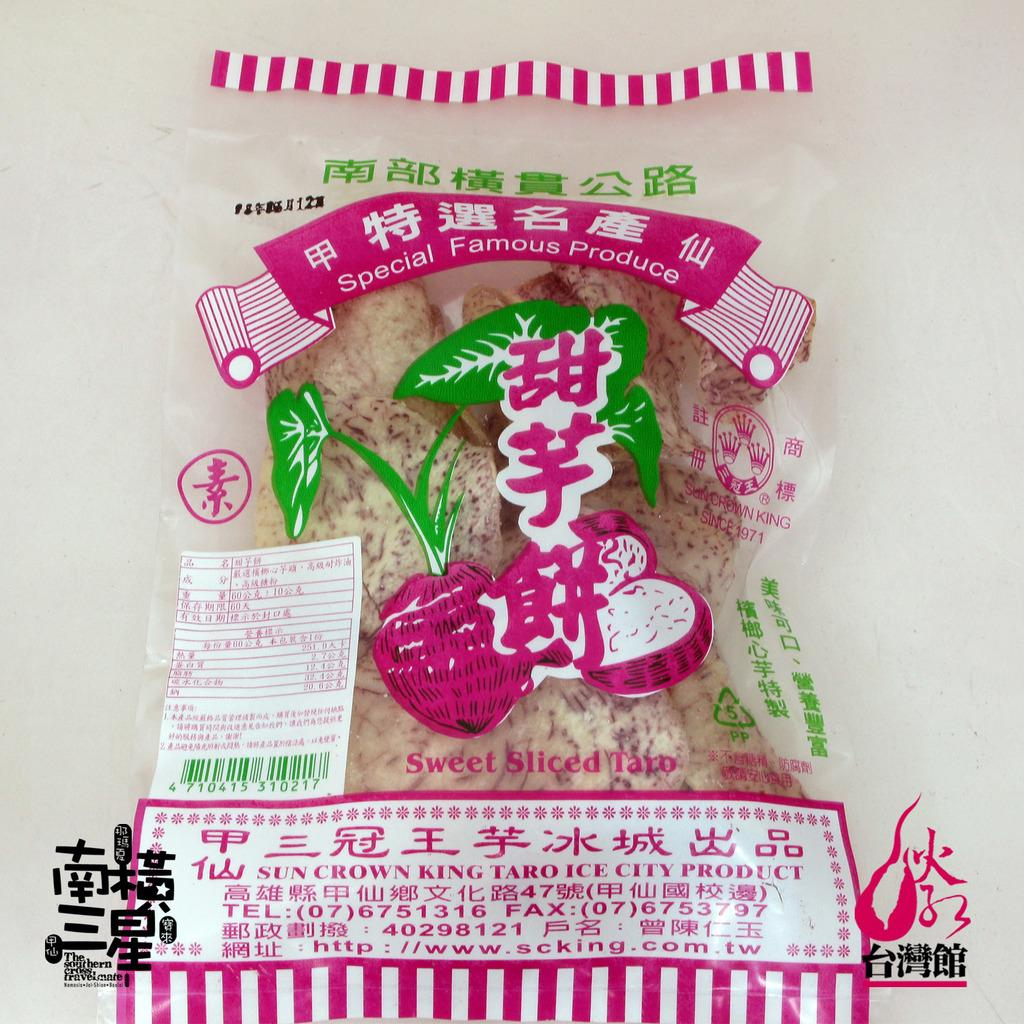<image>
Provide a brief description of the given image. A package of Japanese product the says Special Famous Produce. 